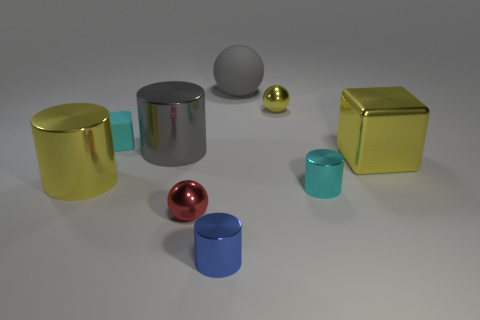Add 1 yellow objects. How many objects exist? 10 Subtract all spheres. How many objects are left? 6 Add 1 blue metal things. How many blue metal things are left? 2 Add 7 small yellow metal spheres. How many small yellow metal spheres exist? 8 Subtract 0 green cylinders. How many objects are left? 9 Subtract all cyan shiny cylinders. Subtract all large gray rubber spheres. How many objects are left? 7 